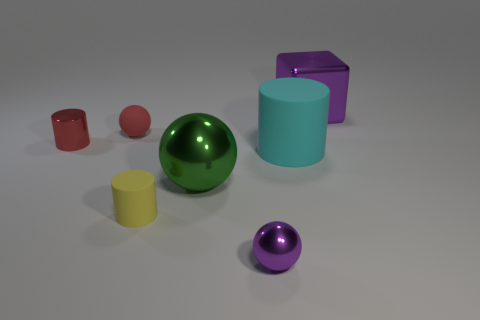What shape is the yellow matte object? cylinder 